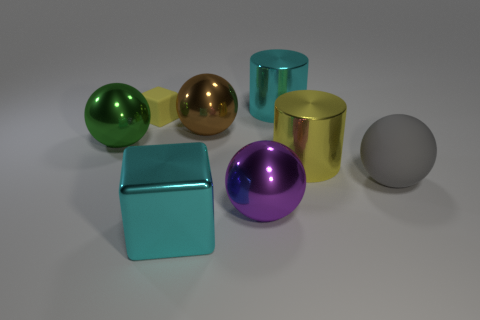Subtract all red balls. Subtract all brown cylinders. How many balls are left? 4 Add 2 big cyan shiny cylinders. How many objects exist? 10 Subtract all cubes. How many objects are left? 6 Subtract all green balls. Subtract all large yellow objects. How many objects are left? 6 Add 3 large yellow things. How many large yellow things are left? 4 Add 7 tiny cubes. How many tiny cubes exist? 8 Subtract 0 green blocks. How many objects are left? 8 